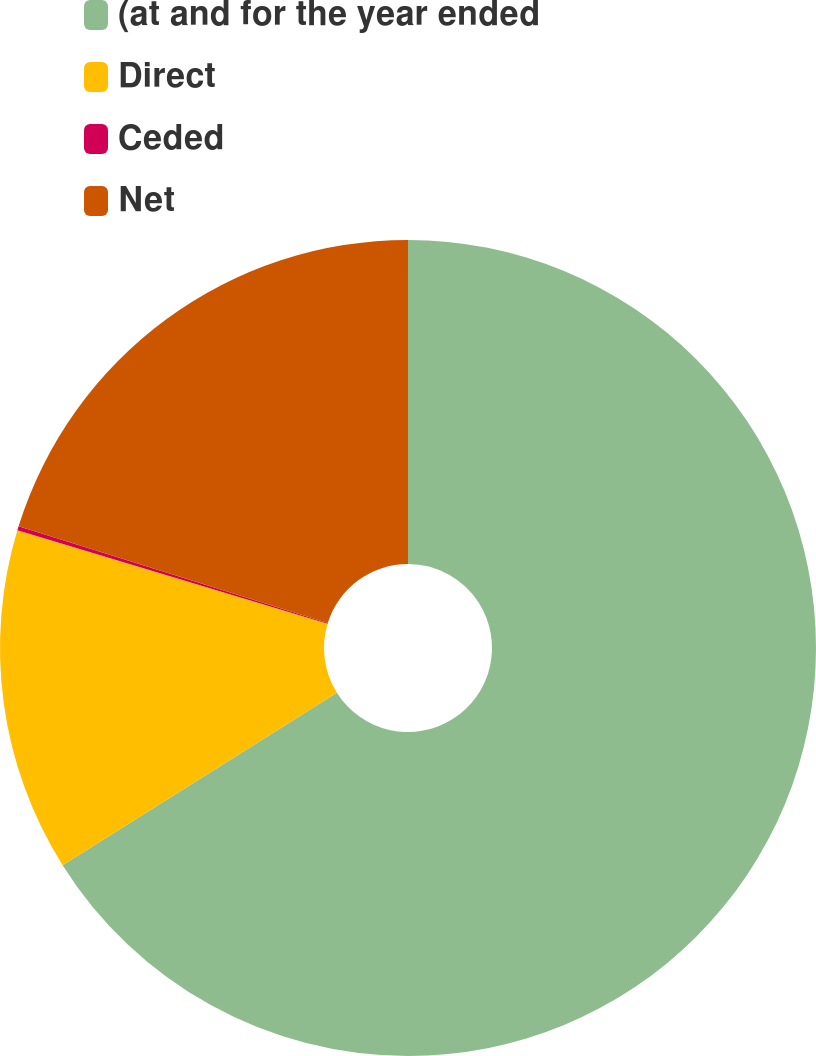Convert chart. <chart><loc_0><loc_0><loc_500><loc_500><pie_chart><fcel>(at and for the year ended<fcel>Direct<fcel>Ceded<fcel>Net<nl><fcel>66.06%<fcel>13.59%<fcel>0.16%<fcel>20.18%<nl></chart> 